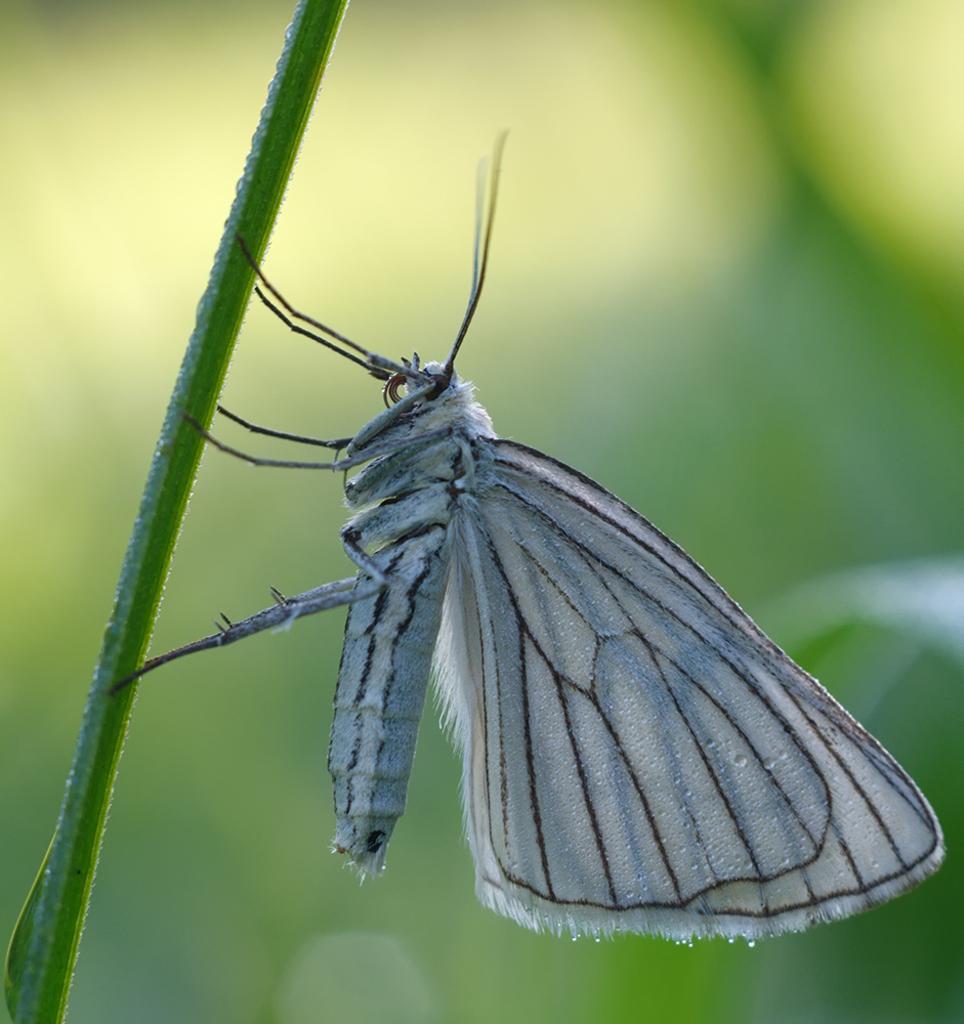Describe this image in one or two sentences. In the image we can see there is a butterfly standing on the plant's stem. 